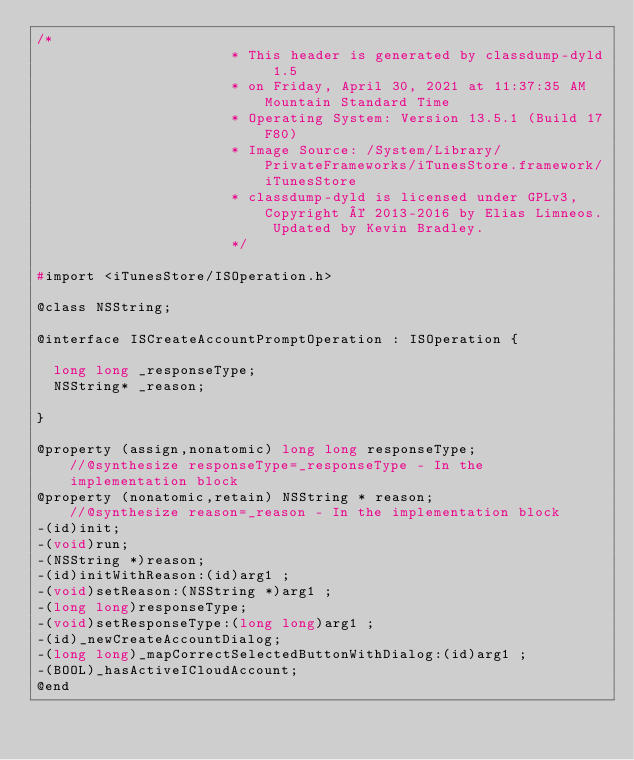Convert code to text. <code><loc_0><loc_0><loc_500><loc_500><_C_>/*
                       * This header is generated by classdump-dyld 1.5
                       * on Friday, April 30, 2021 at 11:37:35 AM Mountain Standard Time
                       * Operating System: Version 13.5.1 (Build 17F80)
                       * Image Source: /System/Library/PrivateFrameworks/iTunesStore.framework/iTunesStore
                       * classdump-dyld is licensed under GPLv3, Copyright © 2013-2016 by Elias Limneos. Updated by Kevin Bradley.
                       */

#import <iTunesStore/ISOperation.h>

@class NSString;

@interface ISCreateAccountPromptOperation : ISOperation {

	long long _responseType;
	NSString* _reason;

}

@property (assign,nonatomic) long long responseType;              //@synthesize responseType=_responseType - In the implementation block
@property (nonatomic,retain) NSString * reason;                   //@synthesize reason=_reason - In the implementation block
-(id)init;
-(void)run;
-(NSString *)reason;
-(id)initWithReason:(id)arg1 ;
-(void)setReason:(NSString *)arg1 ;
-(long long)responseType;
-(void)setResponseType:(long long)arg1 ;
-(id)_newCreateAccountDialog;
-(long long)_mapCorrectSelectedButtonWithDialog:(id)arg1 ;
-(BOOL)_hasActiveICloudAccount;
@end

</code> 